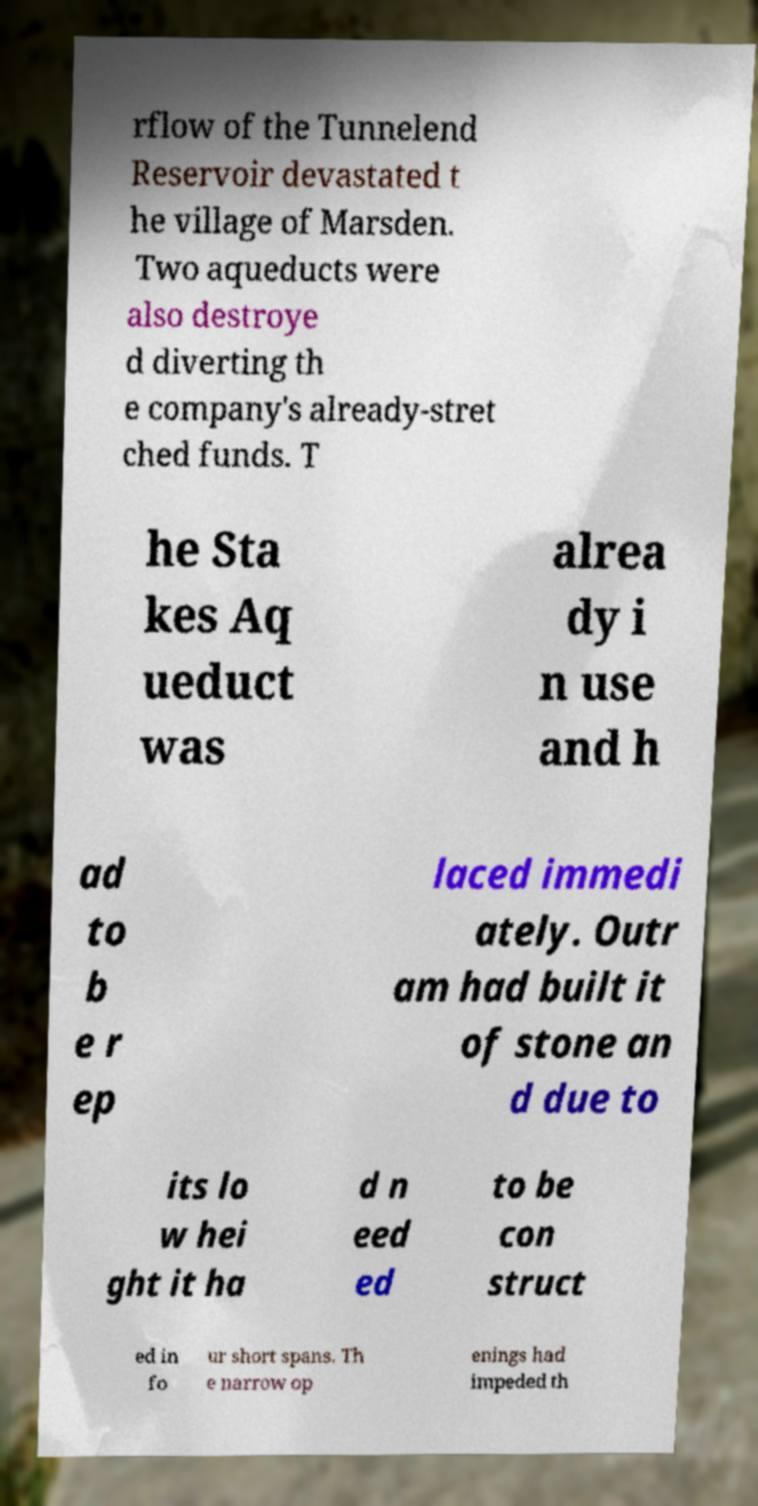Can you read and provide the text displayed in the image?This photo seems to have some interesting text. Can you extract and type it out for me? rflow of the Tunnelend Reservoir devastated t he village of Marsden. Two aqueducts were also destroye d diverting th e company's already-stret ched funds. T he Sta kes Aq ueduct was alrea dy i n use and h ad to b e r ep laced immedi ately. Outr am had built it of stone an d due to its lo w hei ght it ha d n eed ed to be con struct ed in fo ur short spans. Th e narrow op enings had impeded th 